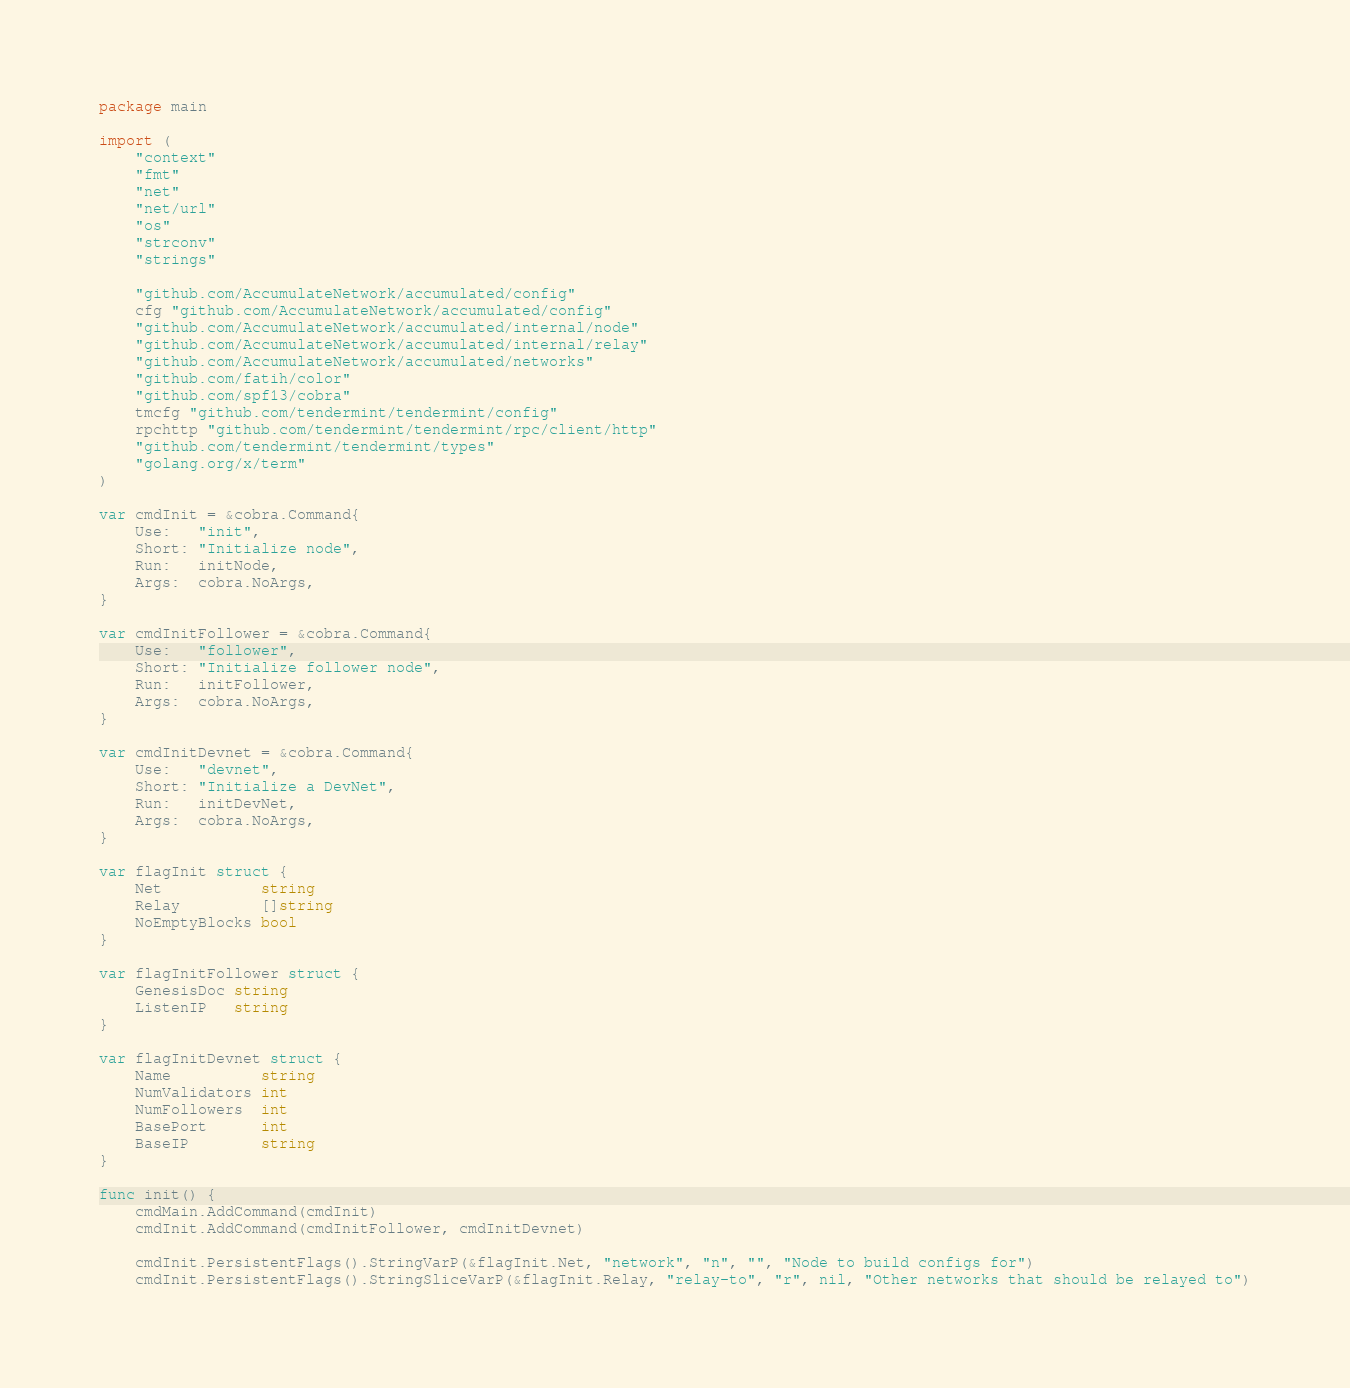Convert code to text. <code><loc_0><loc_0><loc_500><loc_500><_Go_>package main

import (
	"context"
	"fmt"
	"net"
	"net/url"
	"os"
	"strconv"
	"strings"

	"github.com/AccumulateNetwork/accumulated/config"
	cfg "github.com/AccumulateNetwork/accumulated/config"
	"github.com/AccumulateNetwork/accumulated/internal/node"
	"github.com/AccumulateNetwork/accumulated/internal/relay"
	"github.com/AccumulateNetwork/accumulated/networks"
	"github.com/fatih/color"
	"github.com/spf13/cobra"
	tmcfg "github.com/tendermint/tendermint/config"
	rpchttp "github.com/tendermint/tendermint/rpc/client/http"
	"github.com/tendermint/tendermint/types"
	"golang.org/x/term"
)

var cmdInit = &cobra.Command{
	Use:   "init",
	Short: "Initialize node",
	Run:   initNode,
	Args:  cobra.NoArgs,
}

var cmdInitFollower = &cobra.Command{
	Use:   "follower",
	Short: "Initialize follower node",
	Run:   initFollower,
	Args:  cobra.NoArgs,
}

var cmdInitDevnet = &cobra.Command{
	Use:   "devnet",
	Short: "Initialize a DevNet",
	Run:   initDevNet,
	Args:  cobra.NoArgs,
}

var flagInit struct {
	Net           string
	Relay         []string
	NoEmptyBlocks bool
}

var flagInitFollower struct {
	GenesisDoc string
	ListenIP   string
}

var flagInitDevnet struct {
	Name          string
	NumValidators int
	NumFollowers  int
	BasePort      int
	BaseIP        string
}

func init() {
	cmdMain.AddCommand(cmdInit)
	cmdInit.AddCommand(cmdInitFollower, cmdInitDevnet)

	cmdInit.PersistentFlags().StringVarP(&flagInit.Net, "network", "n", "", "Node to build configs for")
	cmdInit.PersistentFlags().StringSliceVarP(&flagInit.Relay, "relay-to", "r", nil, "Other networks that should be relayed to")</code> 